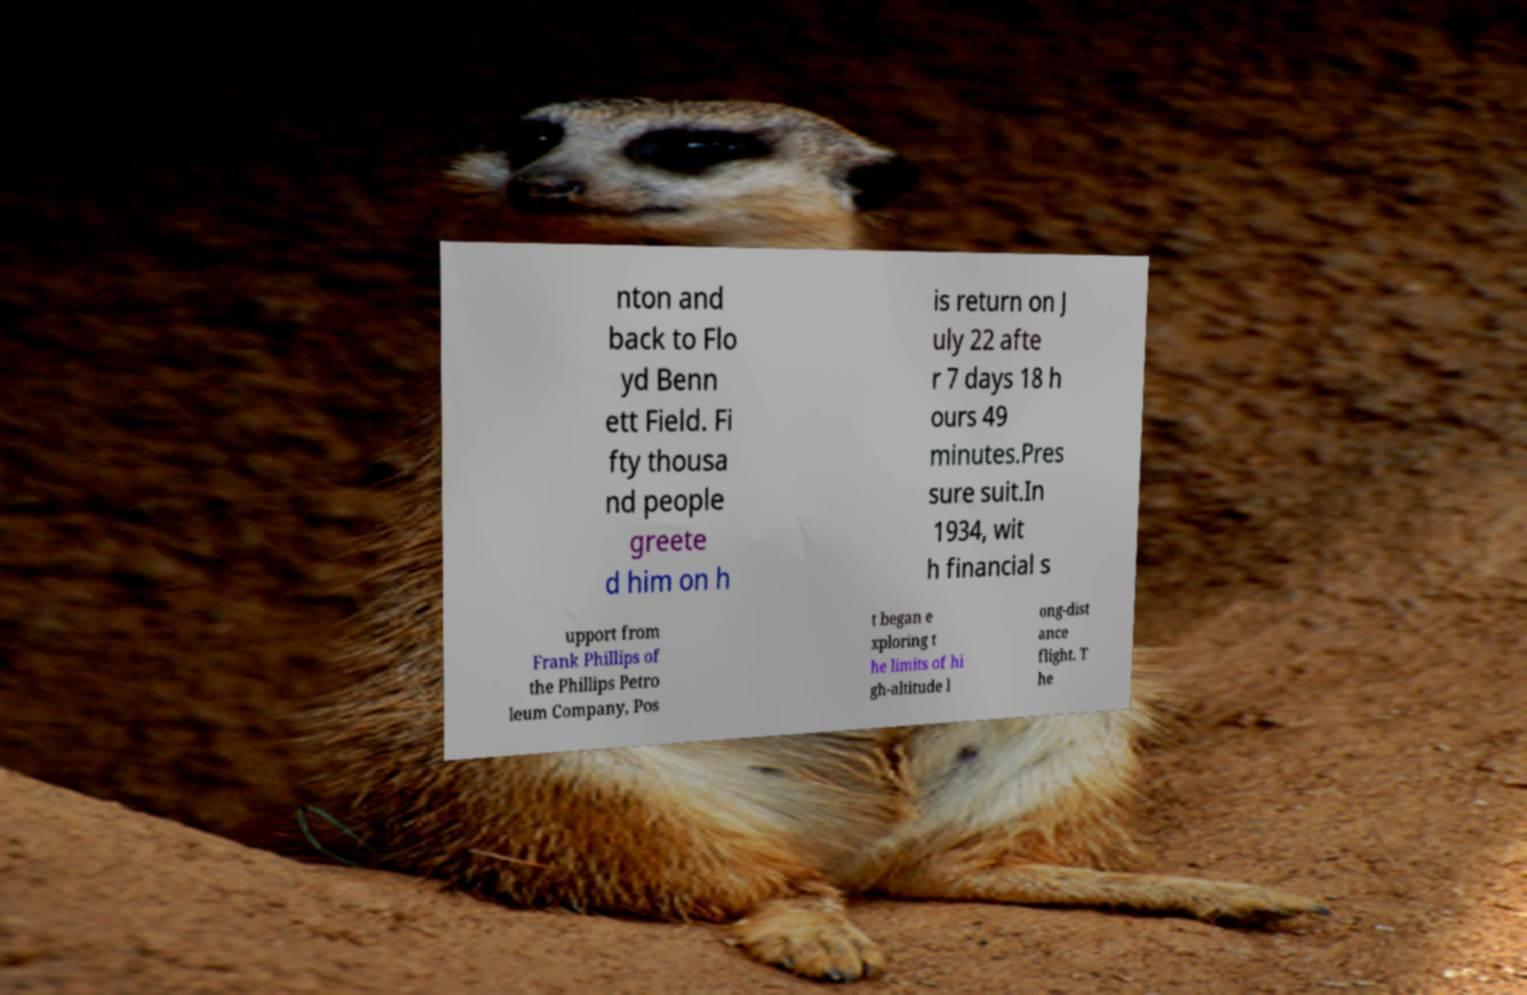For documentation purposes, I need the text within this image transcribed. Could you provide that? nton and back to Flo yd Benn ett Field. Fi fty thousa nd people greete d him on h is return on J uly 22 afte r 7 days 18 h ours 49 minutes.Pres sure suit.In 1934, wit h financial s upport from Frank Phillips of the Phillips Petro leum Company, Pos t began e xploring t he limits of hi gh-altitude l ong-dist ance flight. T he 